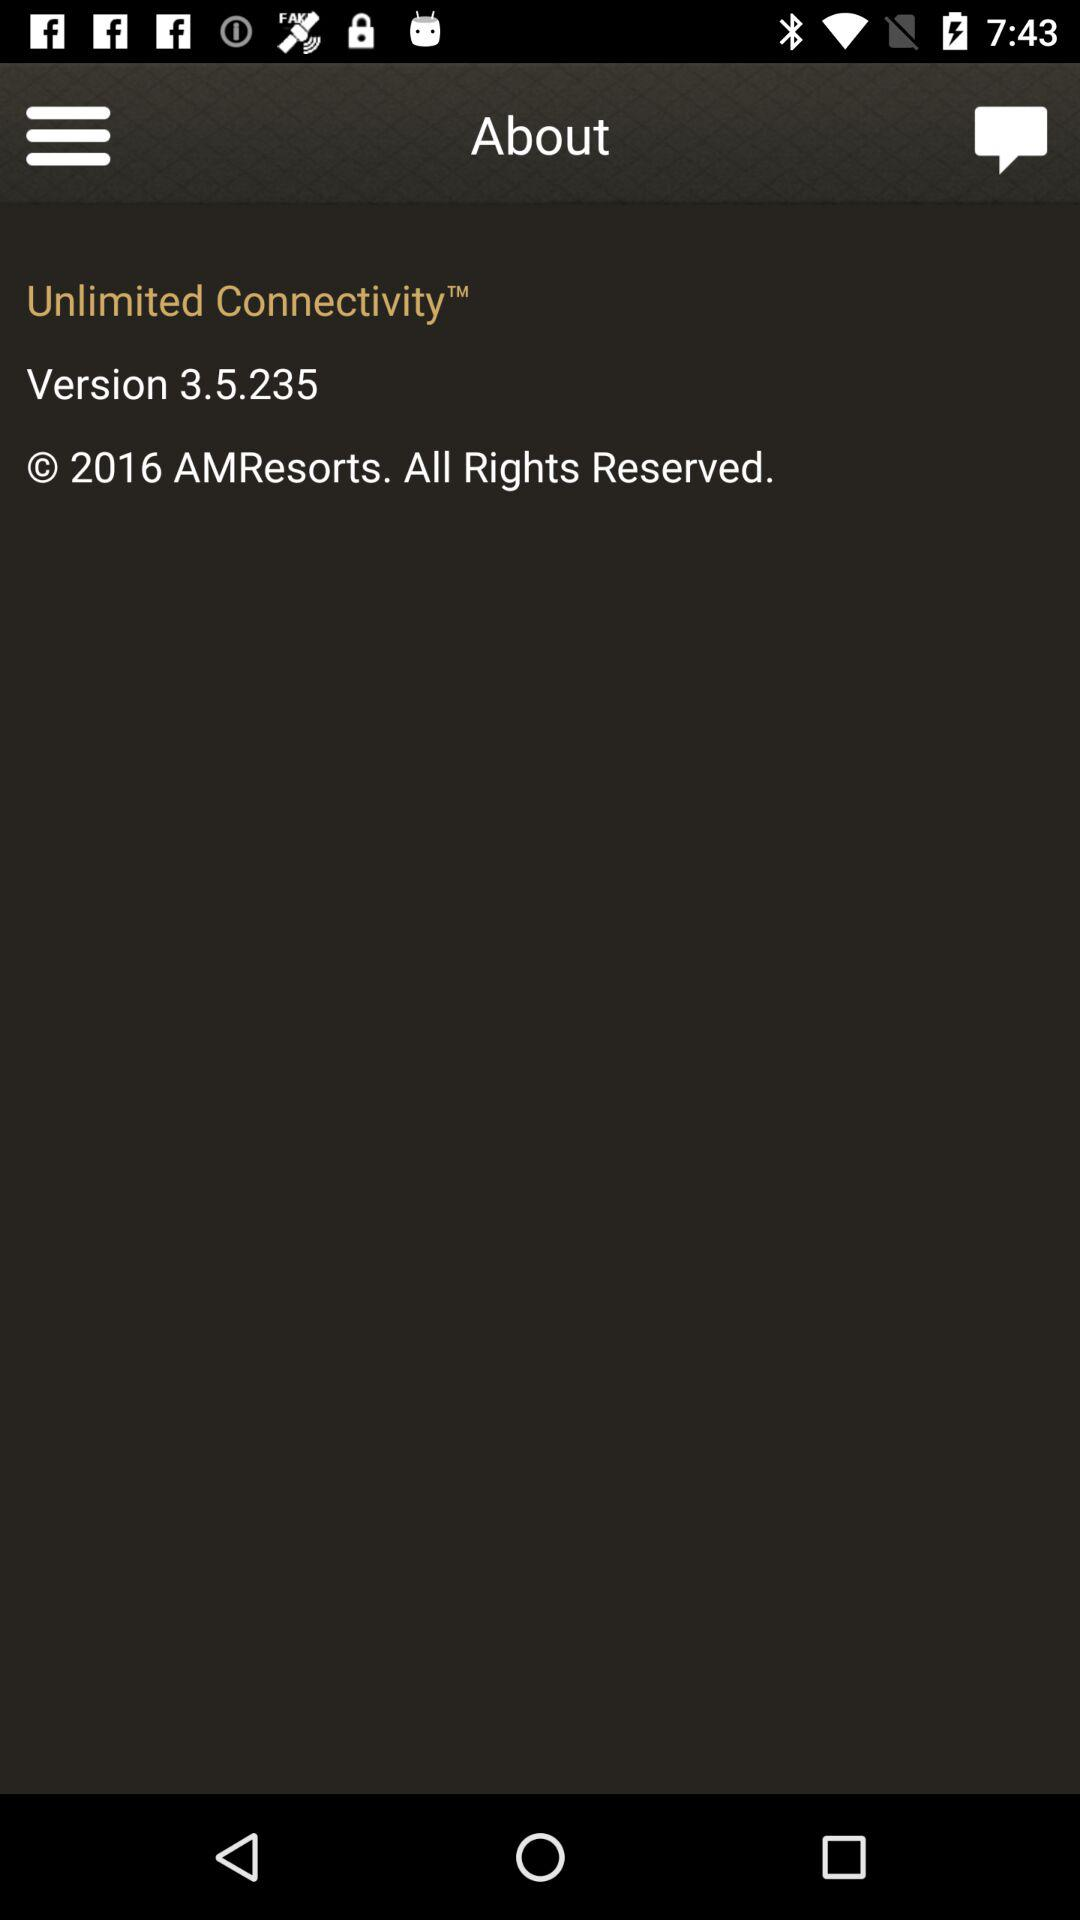What is the version? The version is 3.5.235. 